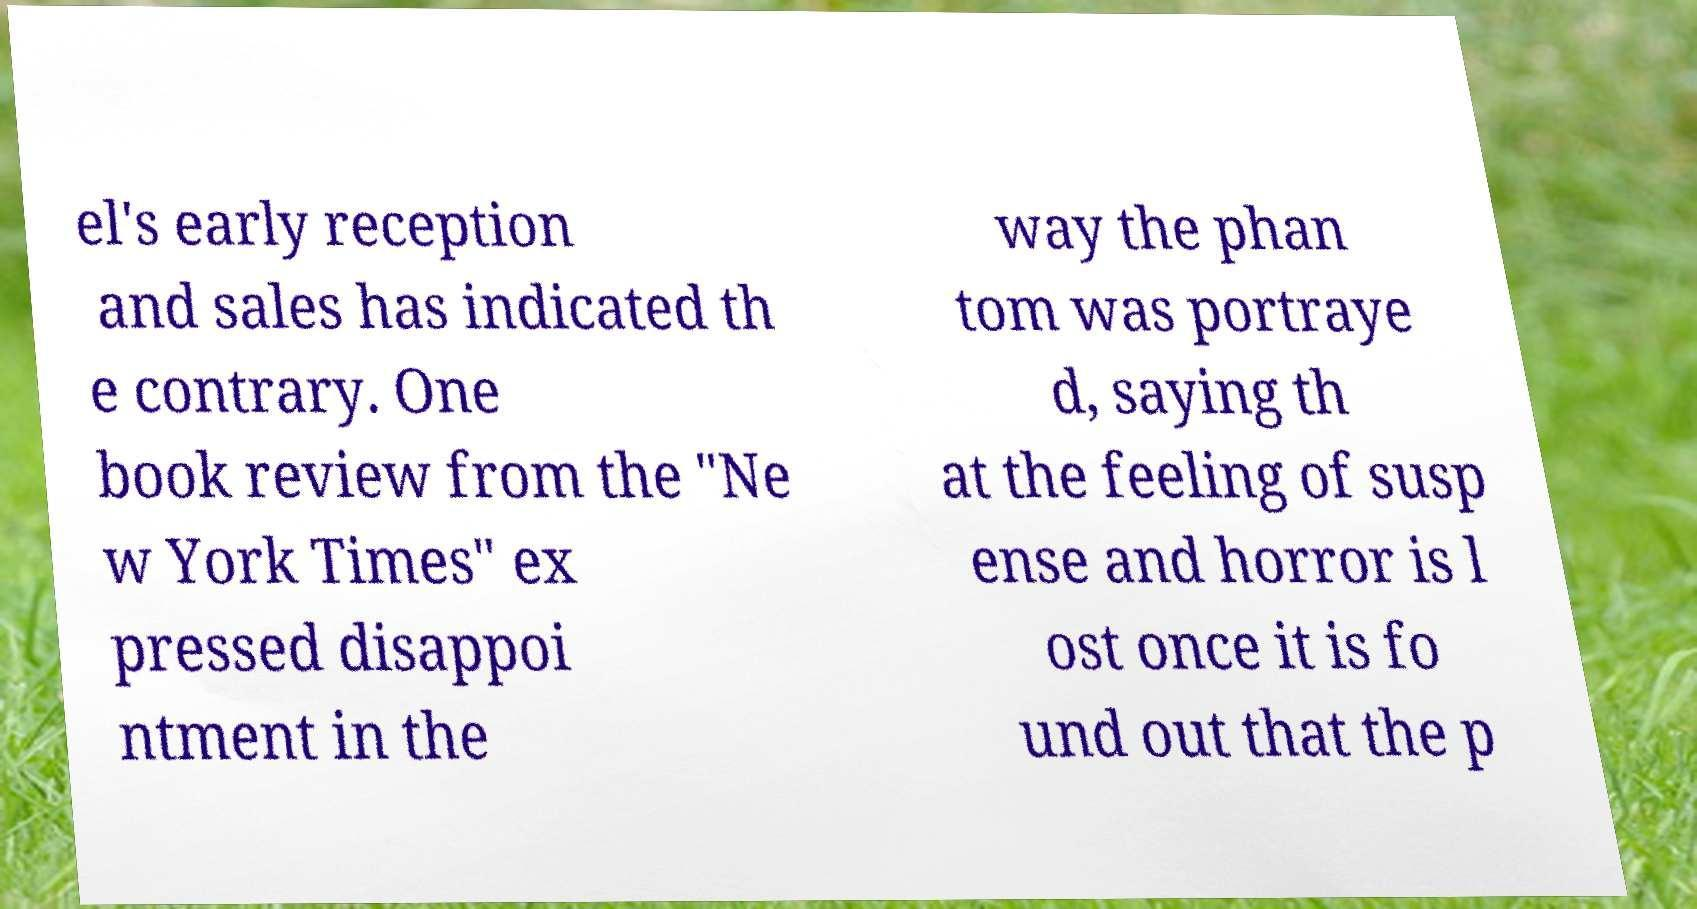For documentation purposes, I need the text within this image transcribed. Could you provide that? el's early reception and sales has indicated th e contrary. One book review from the "Ne w York Times" ex pressed disappoi ntment in the way the phan tom was portraye d, saying th at the feeling of susp ense and horror is l ost once it is fo und out that the p 